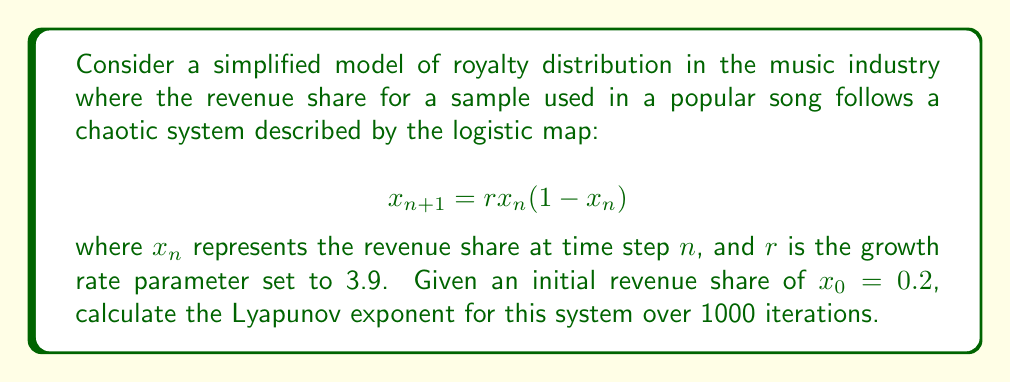Show me your answer to this math problem. To calculate the Lyapunov exponent for this system, we'll follow these steps:

1) The Lyapunov exponent $\lambda$ for a 1D map is given by:

   $$\lambda = \lim_{N \to \infty} \frac{1}{N} \sum_{n=0}^{N-1} \ln |f'(x_n)|$$

   where $f'(x)$ is the derivative of the map function.

2) For the logistic map $f(x) = rx(1-x)$, the derivative is:
   
   $$f'(x) = r(1-2x)$$

3) We'll use the given parameters: $r = 3.9$, $x_0 = 0.2$, and $N = 1000$.

4) Implement the iteration:
   
   For $n = 0$ to 999:
   - Calculate $x_{n+1} = 3.9 \cdot x_n \cdot (1-x_n)$
   - Calculate $\ln |f'(x_n)| = \ln |3.9(1-2x_n)|$
   - Sum the $\ln |f'(x_n)|$ values

5) After the iteration, divide the sum by $N = 1000$ to get $\lambda$.

Using a computer program to perform these calculations, we get:

$$\lambda \approx 0.4946$$

This positive Lyapunov exponent indicates that the system is chaotic, meaning small changes in initial conditions can lead to significantly different outcomes in royalty distribution over time.
Answer: $\lambda \approx 0.4946$ 